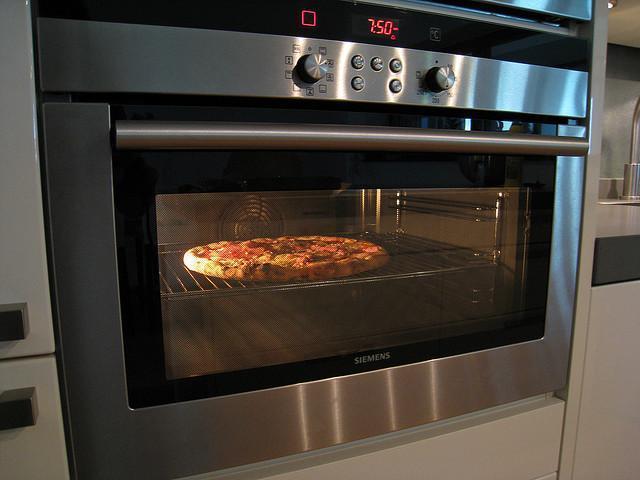Verify the accuracy of this image caption: "The oven is surrounding the pizza.".
Answer yes or no. Yes. 